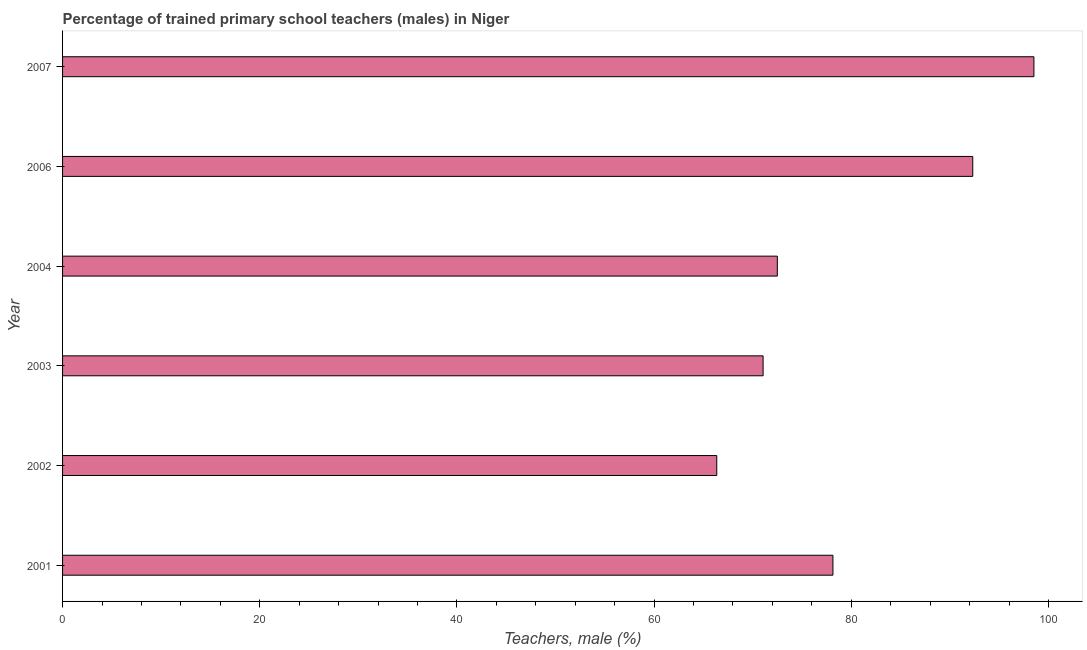Does the graph contain grids?
Give a very brief answer. No. What is the title of the graph?
Your answer should be very brief. Percentage of trained primary school teachers (males) in Niger. What is the label or title of the X-axis?
Provide a short and direct response. Teachers, male (%). What is the percentage of trained male teachers in 2006?
Ensure brevity in your answer.  92.32. Across all years, what is the maximum percentage of trained male teachers?
Offer a very short reply. 98.53. Across all years, what is the minimum percentage of trained male teachers?
Offer a terse response. 66.36. In which year was the percentage of trained male teachers maximum?
Give a very brief answer. 2007. What is the sum of the percentage of trained male teachers?
Your response must be concise. 478.9. What is the difference between the percentage of trained male teachers in 2004 and 2006?
Ensure brevity in your answer.  -19.82. What is the average percentage of trained male teachers per year?
Give a very brief answer. 79.82. What is the median percentage of trained male teachers?
Your response must be concise. 75.32. Do a majority of the years between 2006 and 2007 (inclusive) have percentage of trained male teachers greater than 16 %?
Your response must be concise. Yes. What is the ratio of the percentage of trained male teachers in 2002 to that in 2004?
Ensure brevity in your answer.  0.92. Is the percentage of trained male teachers in 2002 less than that in 2003?
Give a very brief answer. Yes. What is the difference between the highest and the second highest percentage of trained male teachers?
Offer a very short reply. 6.21. What is the difference between the highest and the lowest percentage of trained male teachers?
Your response must be concise. 32.17. Are all the bars in the graph horizontal?
Offer a terse response. Yes. Are the values on the major ticks of X-axis written in scientific E-notation?
Keep it short and to the point. No. What is the Teachers, male (%) of 2001?
Your answer should be compact. 78.14. What is the Teachers, male (%) in 2002?
Your answer should be compact. 66.36. What is the Teachers, male (%) of 2003?
Your answer should be very brief. 71.06. What is the Teachers, male (%) in 2004?
Your answer should be very brief. 72.5. What is the Teachers, male (%) of 2006?
Provide a succinct answer. 92.32. What is the Teachers, male (%) of 2007?
Ensure brevity in your answer.  98.53. What is the difference between the Teachers, male (%) in 2001 and 2002?
Provide a short and direct response. 11.78. What is the difference between the Teachers, male (%) in 2001 and 2003?
Your answer should be compact. 7.08. What is the difference between the Teachers, male (%) in 2001 and 2004?
Offer a terse response. 5.64. What is the difference between the Teachers, male (%) in 2001 and 2006?
Your answer should be very brief. -14.18. What is the difference between the Teachers, male (%) in 2001 and 2007?
Offer a very short reply. -20.39. What is the difference between the Teachers, male (%) in 2002 and 2003?
Ensure brevity in your answer.  -4.7. What is the difference between the Teachers, male (%) in 2002 and 2004?
Your answer should be compact. -6.14. What is the difference between the Teachers, male (%) in 2002 and 2006?
Keep it short and to the point. -25.96. What is the difference between the Teachers, male (%) in 2002 and 2007?
Your response must be concise. -32.17. What is the difference between the Teachers, male (%) in 2003 and 2004?
Ensure brevity in your answer.  -1.44. What is the difference between the Teachers, male (%) in 2003 and 2006?
Your response must be concise. -21.27. What is the difference between the Teachers, male (%) in 2003 and 2007?
Your answer should be compact. -27.47. What is the difference between the Teachers, male (%) in 2004 and 2006?
Offer a terse response. -19.82. What is the difference between the Teachers, male (%) in 2004 and 2007?
Offer a very short reply. -26.03. What is the difference between the Teachers, male (%) in 2006 and 2007?
Provide a succinct answer. -6.2. What is the ratio of the Teachers, male (%) in 2001 to that in 2002?
Offer a very short reply. 1.18. What is the ratio of the Teachers, male (%) in 2001 to that in 2003?
Provide a succinct answer. 1.1. What is the ratio of the Teachers, male (%) in 2001 to that in 2004?
Provide a short and direct response. 1.08. What is the ratio of the Teachers, male (%) in 2001 to that in 2006?
Offer a very short reply. 0.85. What is the ratio of the Teachers, male (%) in 2001 to that in 2007?
Provide a succinct answer. 0.79. What is the ratio of the Teachers, male (%) in 2002 to that in 2003?
Keep it short and to the point. 0.93. What is the ratio of the Teachers, male (%) in 2002 to that in 2004?
Your answer should be very brief. 0.92. What is the ratio of the Teachers, male (%) in 2002 to that in 2006?
Ensure brevity in your answer.  0.72. What is the ratio of the Teachers, male (%) in 2002 to that in 2007?
Make the answer very short. 0.67. What is the ratio of the Teachers, male (%) in 2003 to that in 2006?
Your answer should be very brief. 0.77. What is the ratio of the Teachers, male (%) in 2003 to that in 2007?
Your answer should be compact. 0.72. What is the ratio of the Teachers, male (%) in 2004 to that in 2006?
Your answer should be compact. 0.79. What is the ratio of the Teachers, male (%) in 2004 to that in 2007?
Provide a short and direct response. 0.74. What is the ratio of the Teachers, male (%) in 2006 to that in 2007?
Provide a short and direct response. 0.94. 